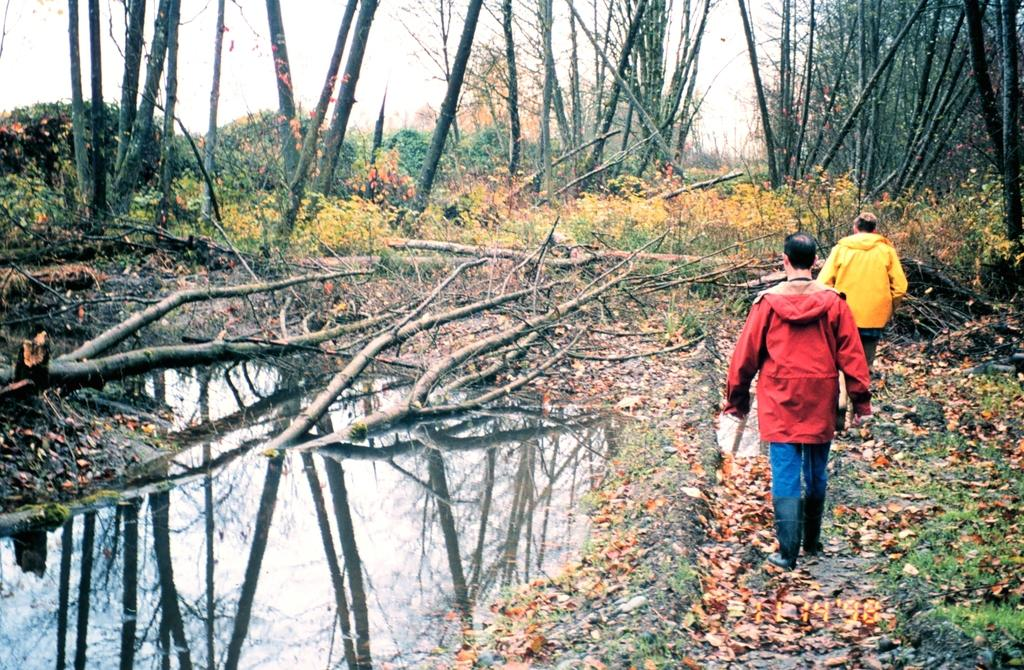How many people are present in the image? There are two persons standing in the image. What type of natural elements can be seen in the image? There are leaves, plants, water, and reflections of trees and the sky visible in the image. Can you describe the reflection in the water? Yes, there is a reflection of trees and the sky in the water. What grade did the person in the image receive for their smoke-filled performance? There is no person performing, and there is no mention of smoke or a performance in the image. 